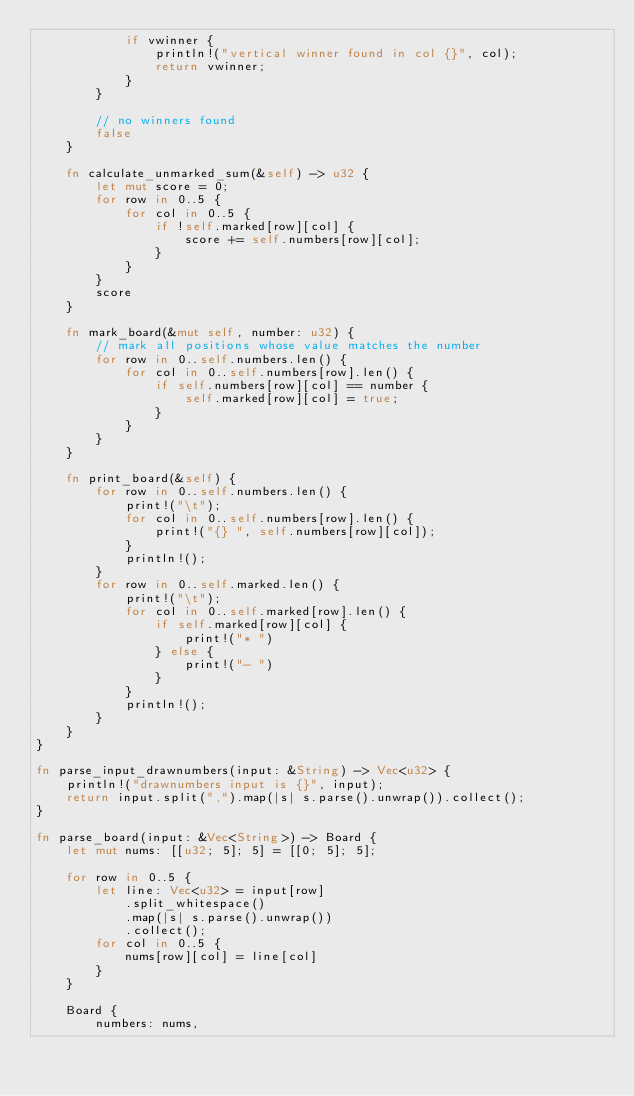<code> <loc_0><loc_0><loc_500><loc_500><_Rust_>            if vwinner {
                println!("vertical winner found in col {}", col);
                return vwinner;
            }
        }

        // no winners found
        false
    }

    fn calculate_unmarked_sum(&self) -> u32 {
        let mut score = 0;
        for row in 0..5 {
            for col in 0..5 {
                if !self.marked[row][col] {
                    score += self.numbers[row][col];
                }
            }
        }
        score
    }

    fn mark_board(&mut self, number: u32) {
        // mark all positions whose value matches the number
        for row in 0..self.numbers.len() {
            for col in 0..self.numbers[row].len() {
                if self.numbers[row][col] == number {
                    self.marked[row][col] = true;
                }
            }
        }
    }

    fn print_board(&self) {
        for row in 0..self.numbers.len() {
            print!("\t");
            for col in 0..self.numbers[row].len() {
                print!("{} ", self.numbers[row][col]);
            }
            println!();
        }
        for row in 0..self.marked.len() {
            print!("\t");
            for col in 0..self.marked[row].len() {
                if self.marked[row][col] {
                    print!("* ")
                } else {
                    print!("- ")
                }
            }
            println!();
        }
    }
}

fn parse_input_drawnumbers(input: &String) -> Vec<u32> {
    println!("drawnumbers input is {}", input);
    return input.split(",").map(|s| s.parse().unwrap()).collect();
}

fn parse_board(input: &Vec<String>) -> Board {
    let mut nums: [[u32; 5]; 5] = [[0; 5]; 5];

    for row in 0..5 {
        let line: Vec<u32> = input[row]
            .split_whitespace()
            .map(|s| s.parse().unwrap())
            .collect();
        for col in 0..5 {
            nums[row][col] = line[col]
        }
    }

    Board {
        numbers: nums,</code> 